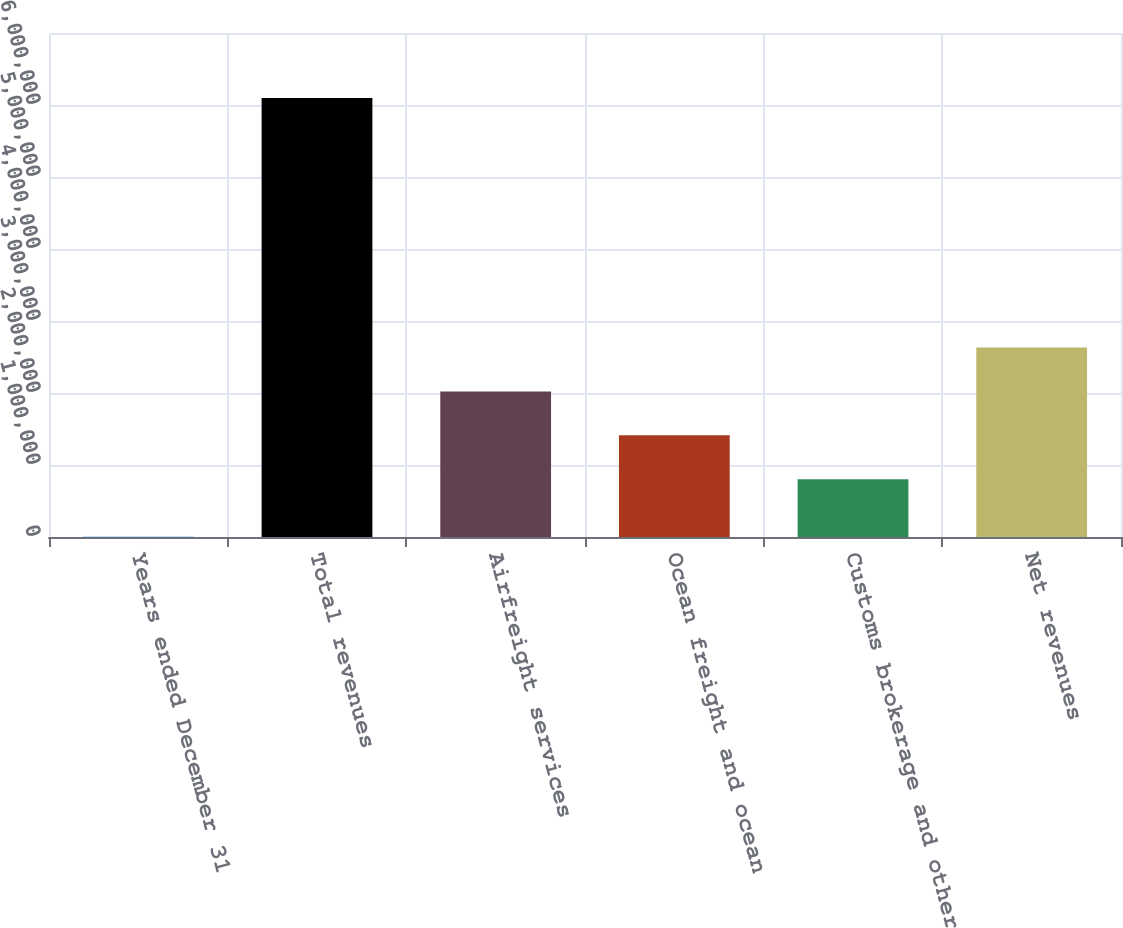<chart> <loc_0><loc_0><loc_500><loc_500><bar_chart><fcel>Years ended December 31<fcel>Total revenues<fcel>Airfreight services<fcel>Ocean freight and ocean<fcel>Customs brokerage and other<fcel>Net revenues<nl><fcel>2016<fcel>6.09804e+06<fcel>2.02234e+06<fcel>1.41274e+06<fcel>803135<fcel>2.63194e+06<nl></chart> 